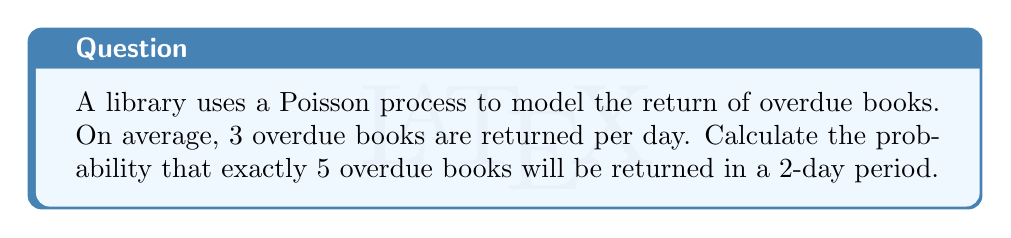Give your solution to this math problem. To solve this problem, we'll use the Poisson distribution formula:

$$P(X = k) = \frac{e^{-\lambda} \lambda^k}{k!}$$

Where:
- $\lambda$ is the average rate of occurrences
- $k$ is the number of occurrences we're interested in
- $e$ is Euler's number (approximately 2.71828)

Steps:
1) First, calculate $\lambda$ for a 2-day period:
   $\lambda = 3 \text{ books/day} \times 2 \text{ days} = 6 \text{ books}$

2) Now, we want the probability of exactly 5 books being returned, so $k = 5$

3) Plug these values into the Poisson distribution formula:

   $$P(X = 5) = \frac{e^{-6} 6^5}{5!}$$

4) Calculate:
   $$P(X = 5) = \frac{2.71828^{-6} \times 6^5}{5 \times 4 \times 3 \times 2 \times 1}$$

5) Simplify:
   $$P(X = 5) = \frac{0.00248 \times 7776}{120} \approx 0.1606$$

6) Convert to a percentage:
   $0.1606 \times 100\% = 16.06\%$
Answer: 16.06% 